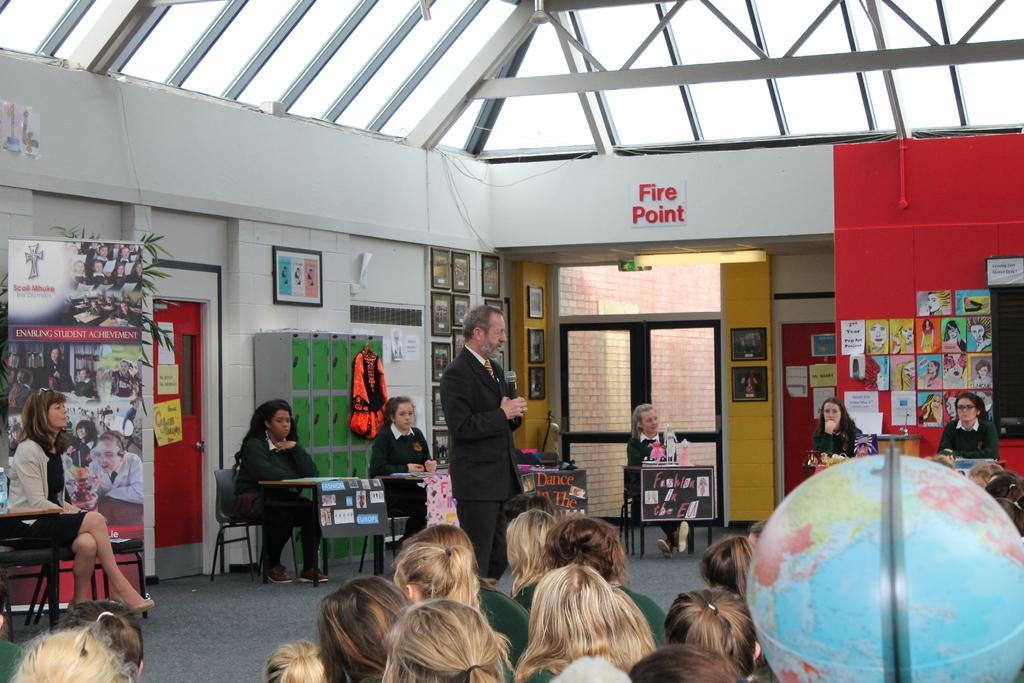In one or two sentences, can you explain what this image depicts? On the right side there is a globe. Two persons are sitting. And there is a board with some posters. Another person is standing and holding a mic. In the back some persons are sitting on chairs. Also there are boards with something pasted on that. There are many people sitting. There is a banner. Also there is a shelf. On that something is hanged. And there are doors. There is a wall. On the wall there are photo frames and something is written. 